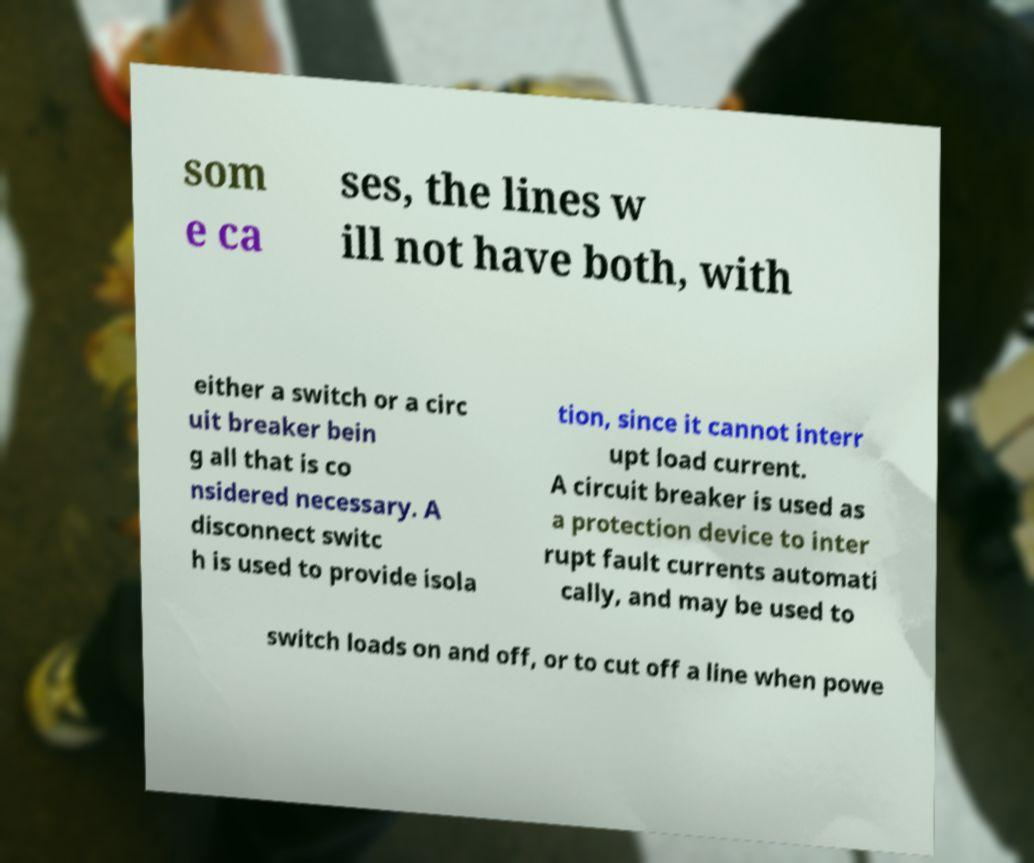Please identify and transcribe the text found in this image. som e ca ses, the lines w ill not have both, with either a switch or a circ uit breaker bein g all that is co nsidered necessary. A disconnect switc h is used to provide isola tion, since it cannot interr upt load current. A circuit breaker is used as a protection device to inter rupt fault currents automati cally, and may be used to switch loads on and off, or to cut off a line when powe 